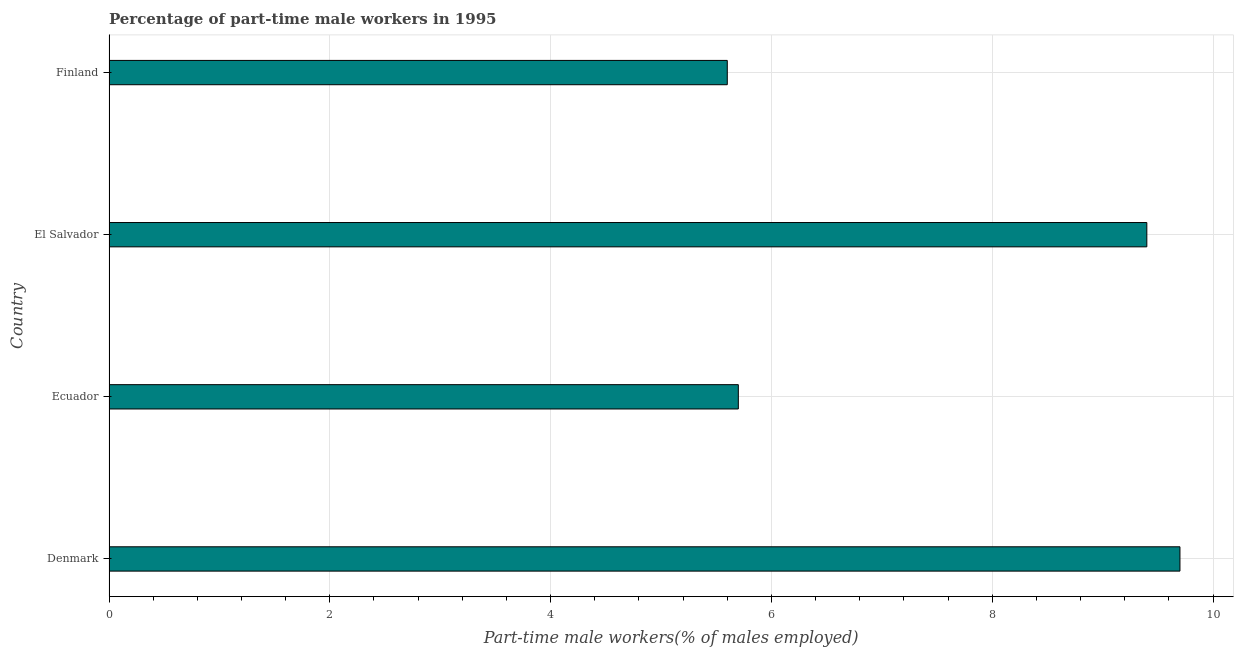Does the graph contain any zero values?
Provide a short and direct response. No. Does the graph contain grids?
Keep it short and to the point. Yes. What is the title of the graph?
Give a very brief answer. Percentage of part-time male workers in 1995. What is the label or title of the X-axis?
Ensure brevity in your answer.  Part-time male workers(% of males employed). What is the label or title of the Y-axis?
Your answer should be compact. Country. What is the percentage of part-time male workers in Ecuador?
Provide a short and direct response. 5.7. Across all countries, what is the maximum percentage of part-time male workers?
Your response must be concise. 9.7. Across all countries, what is the minimum percentage of part-time male workers?
Provide a succinct answer. 5.6. In which country was the percentage of part-time male workers maximum?
Your answer should be very brief. Denmark. What is the sum of the percentage of part-time male workers?
Keep it short and to the point. 30.4. What is the median percentage of part-time male workers?
Offer a terse response. 7.55. In how many countries, is the percentage of part-time male workers greater than 7.6 %?
Offer a terse response. 2. What is the ratio of the percentage of part-time male workers in Ecuador to that in El Salvador?
Ensure brevity in your answer.  0.61. Is the difference between the percentage of part-time male workers in El Salvador and Finland greater than the difference between any two countries?
Keep it short and to the point. No. What is the difference between the highest and the second highest percentage of part-time male workers?
Provide a short and direct response. 0.3. Is the sum of the percentage of part-time male workers in El Salvador and Finland greater than the maximum percentage of part-time male workers across all countries?
Provide a succinct answer. Yes. What is the difference between the highest and the lowest percentage of part-time male workers?
Ensure brevity in your answer.  4.1. How many bars are there?
Your answer should be very brief. 4. What is the difference between two consecutive major ticks on the X-axis?
Offer a very short reply. 2. What is the Part-time male workers(% of males employed) of Denmark?
Make the answer very short. 9.7. What is the Part-time male workers(% of males employed) of Ecuador?
Keep it short and to the point. 5.7. What is the Part-time male workers(% of males employed) in El Salvador?
Your answer should be compact. 9.4. What is the Part-time male workers(% of males employed) in Finland?
Ensure brevity in your answer.  5.6. What is the difference between the Part-time male workers(% of males employed) in Denmark and El Salvador?
Provide a short and direct response. 0.3. What is the difference between the Part-time male workers(% of males employed) in Denmark and Finland?
Keep it short and to the point. 4.1. What is the difference between the Part-time male workers(% of males employed) in Ecuador and El Salvador?
Keep it short and to the point. -3.7. What is the difference between the Part-time male workers(% of males employed) in El Salvador and Finland?
Provide a succinct answer. 3.8. What is the ratio of the Part-time male workers(% of males employed) in Denmark to that in Ecuador?
Offer a terse response. 1.7. What is the ratio of the Part-time male workers(% of males employed) in Denmark to that in El Salvador?
Your response must be concise. 1.03. What is the ratio of the Part-time male workers(% of males employed) in Denmark to that in Finland?
Your answer should be compact. 1.73. What is the ratio of the Part-time male workers(% of males employed) in Ecuador to that in El Salvador?
Keep it short and to the point. 0.61. What is the ratio of the Part-time male workers(% of males employed) in Ecuador to that in Finland?
Your answer should be very brief. 1.02. What is the ratio of the Part-time male workers(% of males employed) in El Salvador to that in Finland?
Make the answer very short. 1.68. 